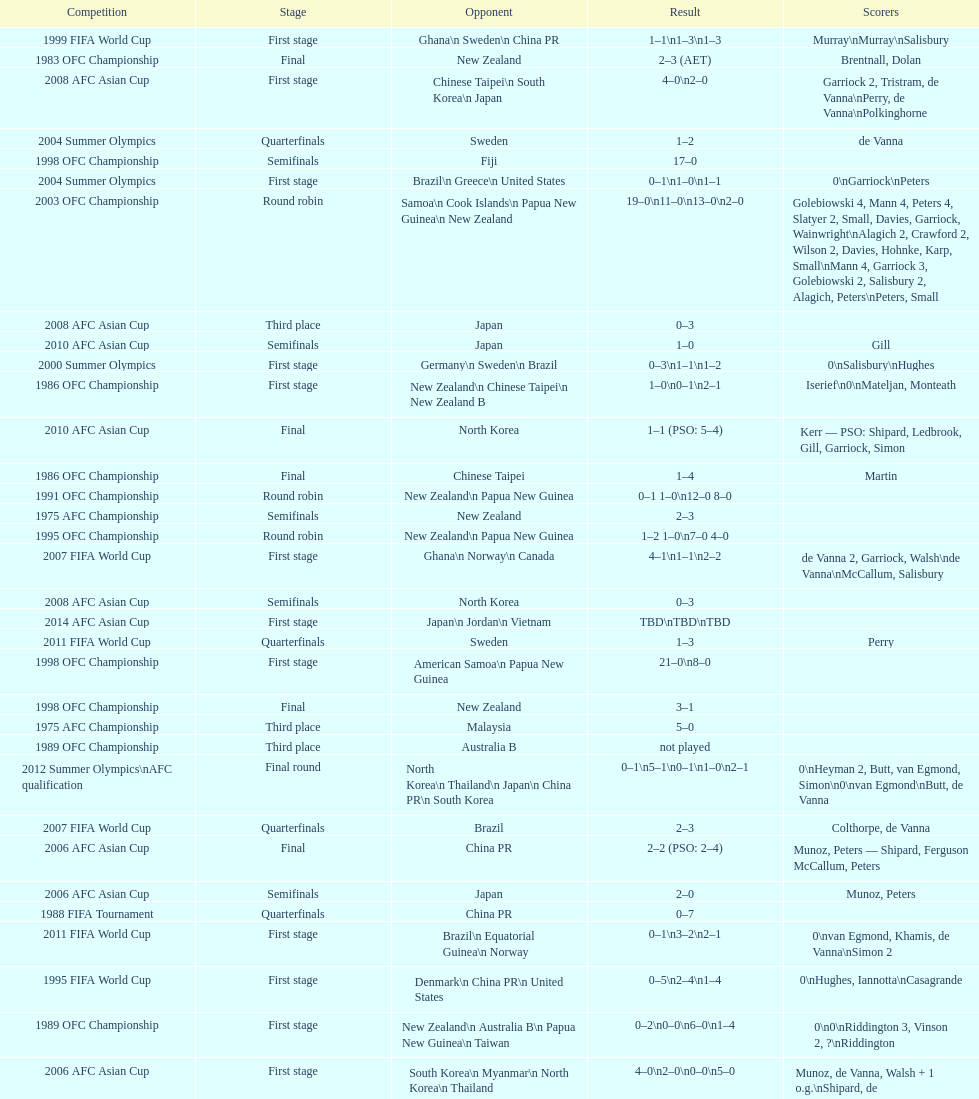How many points were scored in the final round of the 2012 summer olympics afc qualification? 12. 